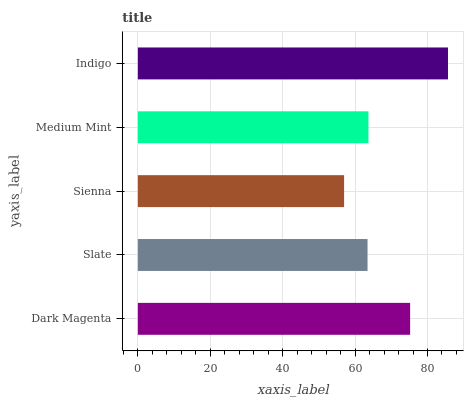Is Sienna the minimum?
Answer yes or no. Yes. Is Indigo the maximum?
Answer yes or no. Yes. Is Slate the minimum?
Answer yes or no. No. Is Slate the maximum?
Answer yes or no. No. Is Dark Magenta greater than Slate?
Answer yes or no. Yes. Is Slate less than Dark Magenta?
Answer yes or no. Yes. Is Slate greater than Dark Magenta?
Answer yes or no. No. Is Dark Magenta less than Slate?
Answer yes or no. No. Is Medium Mint the high median?
Answer yes or no. Yes. Is Medium Mint the low median?
Answer yes or no. Yes. Is Indigo the high median?
Answer yes or no. No. Is Slate the low median?
Answer yes or no. No. 